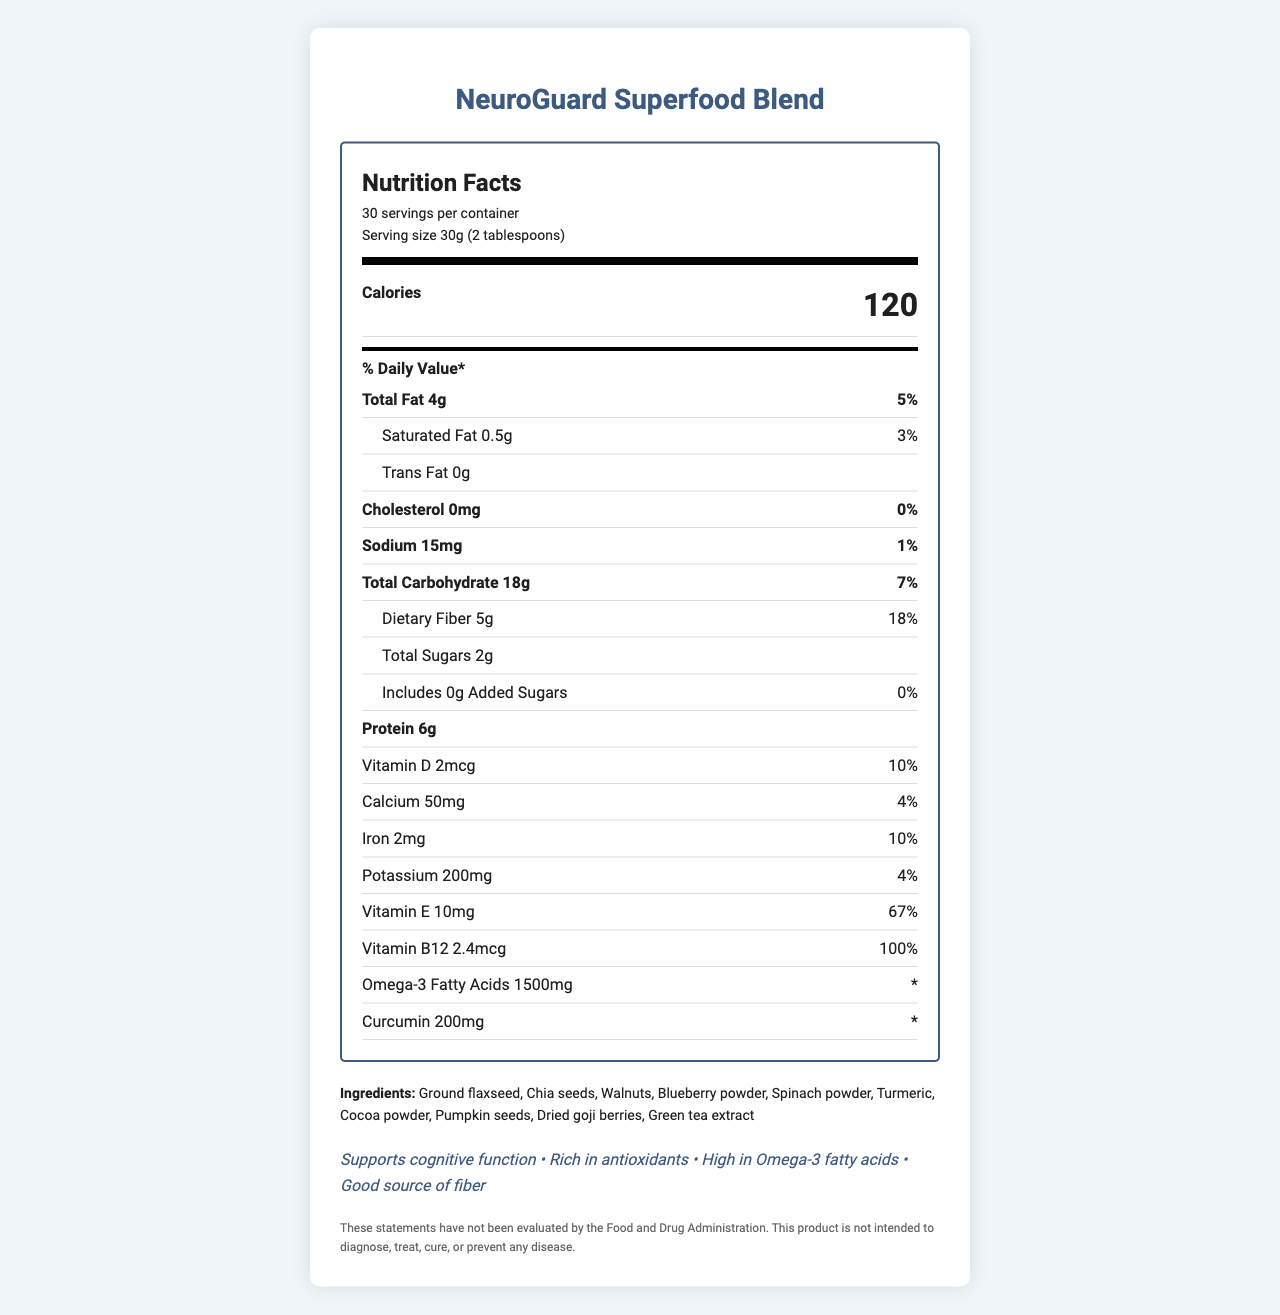what is the product name? The product name is prominently displayed at the top and in the title of the document.
Answer: NeuroGuard Superfood Blend how many servings per container? The document states that there are 30 servings per container.
Answer: 30 servings what is the serving size? The document specifies that the serving size is 30g, equivalent to 2 tablespoons.
Answer: 30g (2 tablespoons) what is the total fat per serving? The total fat content per serving is indicated as 4g.
Answer: 4g how much protein does each serving provide? Each serving contains 6g of protein, as stated in the document.
Answer: 6g what is the daily value percentage for saturated fat? The daily value percentage for saturated fat is given as 3%.
Answer: 3% how much sugar does this product contain per serving? The document states that each serving includes 2g of total sugars.
Answer: 2g what are some of the key ingredients in this blend? (Multiple Choice) (i) Green tea extract (ii) Dried goji berries (iii) Walnuts (iv) Cocoa powder The document lists all these ingredients as part of the blend.
Answer: All of the above which vitamin has the highest daily value percentage per serving? A. Vitamin D B. Vitamin E C. Vitamin B12 D. Iron Vitamin B12 has a daily value of 100%, which is higher than Vitamin D (10%), Vitamin E (67%), and Iron (10%).
Answer: C. Vitamin B12 does this product contain any tree nuts? The allergen information states that the product contains tree nuts (walnuts).
Answer: Yes is there any trans fat in this product? The document mentions that the product contains 0g of trans fat.
Answer: No does the product contain any added sugars? The document states that the amount of added sugars is 0g, with a daily value of 0%.
Answer: No what benefits does the product claim to offer? These claims are explicitly listed in the document.
Answer: Supports cognitive function, Rich in antioxidants, High in Omega-3 fatty acids, Good source of fiber can you summarize the document? The explanation encompasses the entire document, its structure, and key information points.
Answer: The document provides detailed nutritional information for "NeuroGuard Superfood Blend", a brain-boosting product designed for Alzheimer's prevention. It includes the nutrition facts, ingredient list, allergen information, storage instructions, manufacturer's details, and various health claims. It highlights its high Omega-3, fiber, and antioxidant content, and specific nutrients like curcumin, vitamins, and minerals. who collaborated in the development of this product? The collaboration with neuroscientists from Stanford University is mentioned in the research notes, but the specific individuals or teams involved are not listed in the visual content.
Answer: Not enough information 